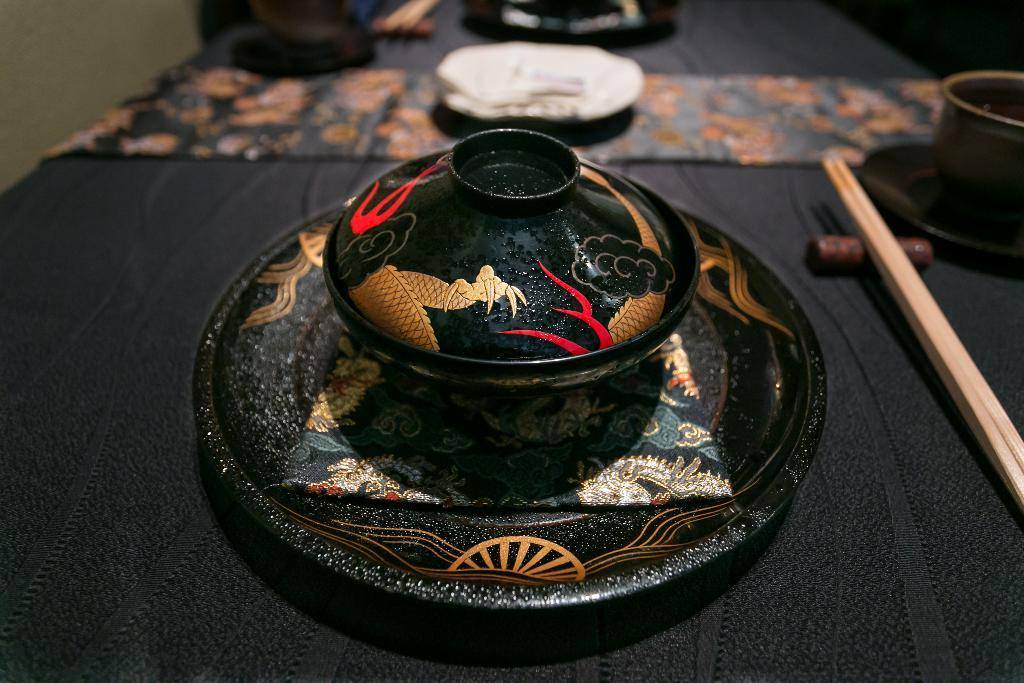What type of dishware is present on the table in the image? There is a black plate and a bowl with chopsticks in the image. What color is the table in the image? The table in the image is black. What type of shop can be seen in the background of the image? There is no shop visible in the image; it only shows a black plate, a bowl with chopsticks, and a black table. 